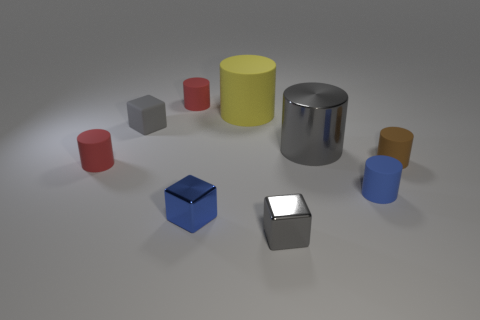Subtract all big metal cylinders. How many cylinders are left? 5 Subtract all green blocks. How many red cylinders are left? 2 Subtract all blue cubes. How many cubes are left? 2 Subtract 4 cylinders. How many cylinders are left? 2 Add 1 blue rubber cylinders. How many objects exist? 10 Subtract all blocks. How many objects are left? 6 Subtract all purple cubes. Subtract all green cylinders. How many cubes are left? 3 Add 5 tiny gray cylinders. How many tiny gray cylinders exist? 5 Subtract 0 brown spheres. How many objects are left? 9 Subtract all gray rubber objects. Subtract all brown cylinders. How many objects are left? 7 